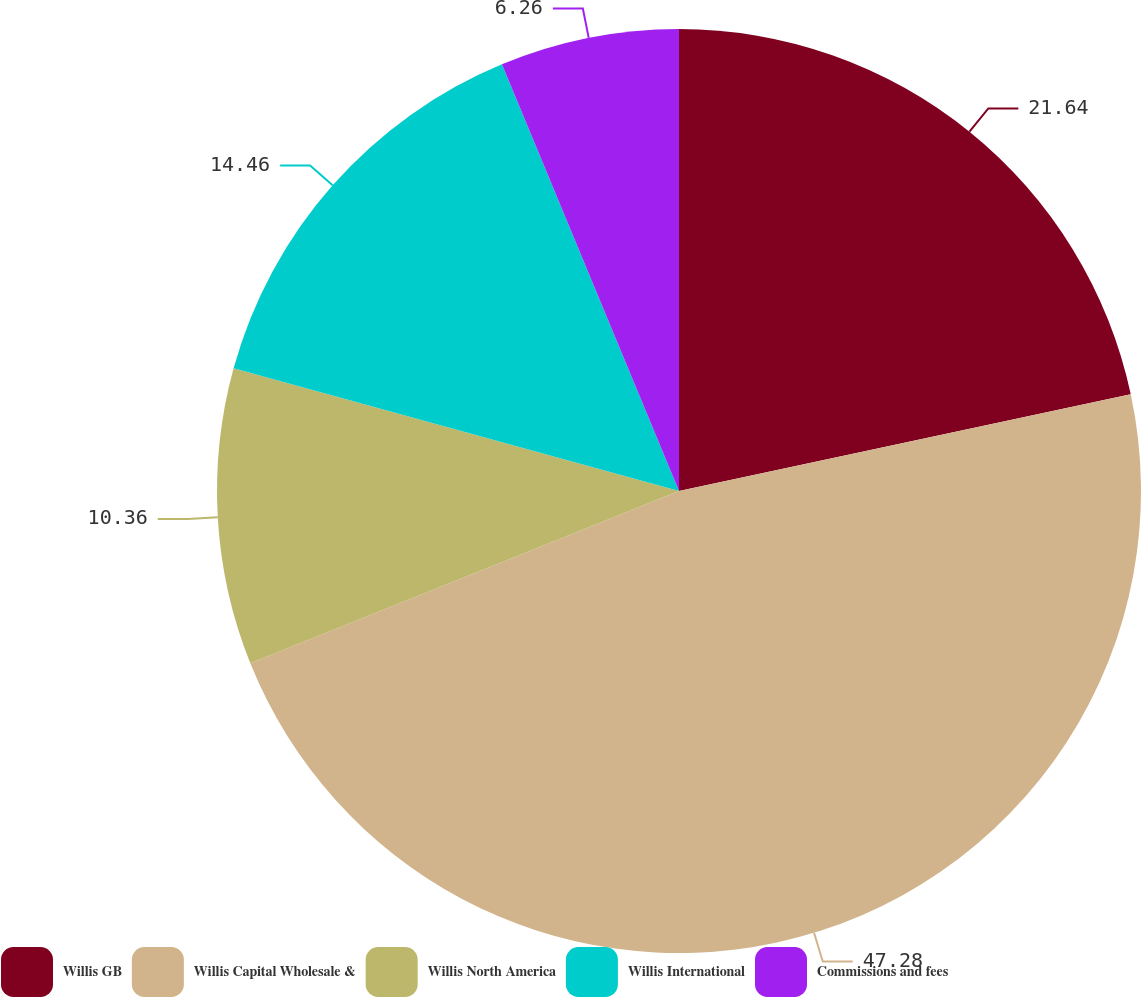Convert chart. <chart><loc_0><loc_0><loc_500><loc_500><pie_chart><fcel>Willis GB<fcel>Willis Capital Wholesale &<fcel>Willis North America<fcel>Willis International<fcel>Commissions and fees<nl><fcel>21.64%<fcel>47.27%<fcel>10.36%<fcel>14.46%<fcel>6.26%<nl></chart> 